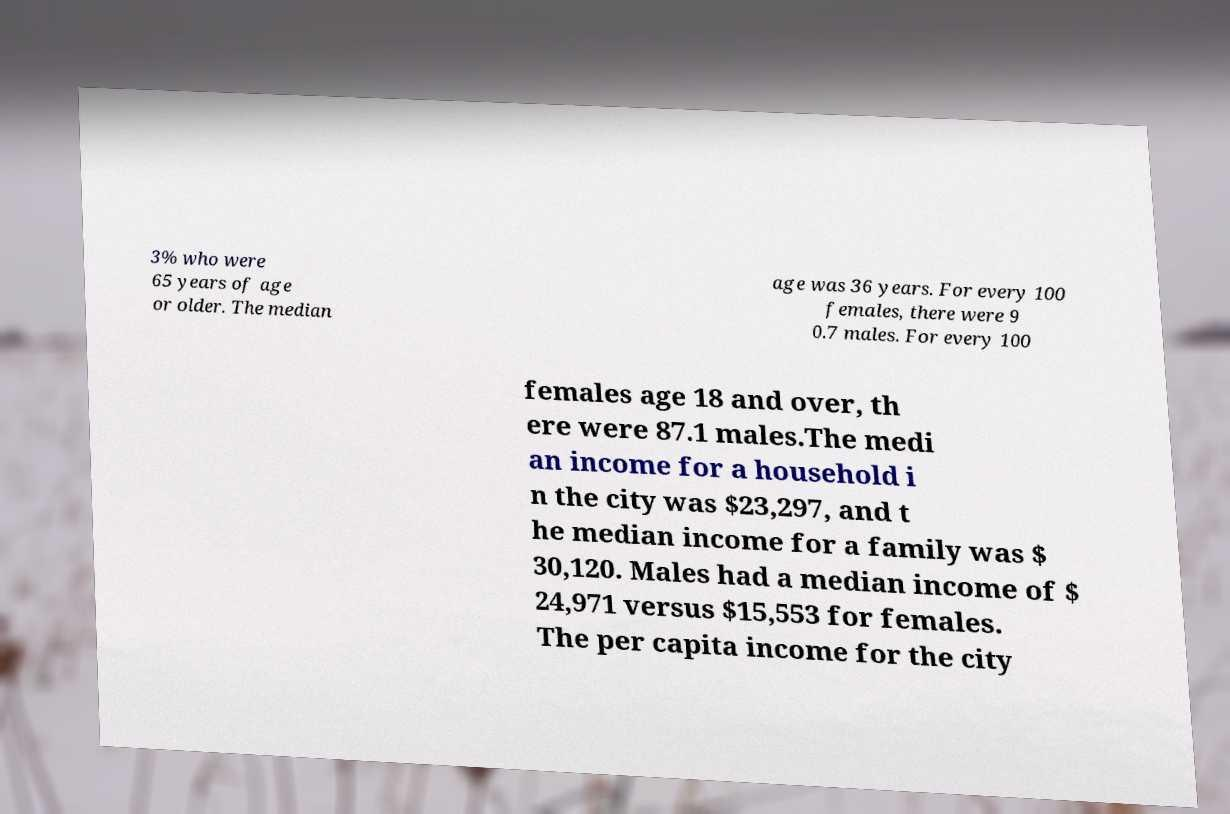For documentation purposes, I need the text within this image transcribed. Could you provide that? 3% who were 65 years of age or older. The median age was 36 years. For every 100 females, there were 9 0.7 males. For every 100 females age 18 and over, th ere were 87.1 males.The medi an income for a household i n the city was $23,297, and t he median income for a family was $ 30,120. Males had a median income of $ 24,971 versus $15,553 for females. The per capita income for the city 